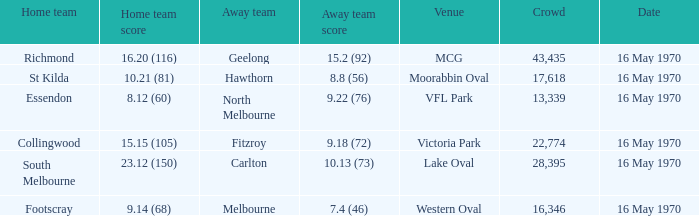What away team scored 9.18 (72)? Fitzroy. 